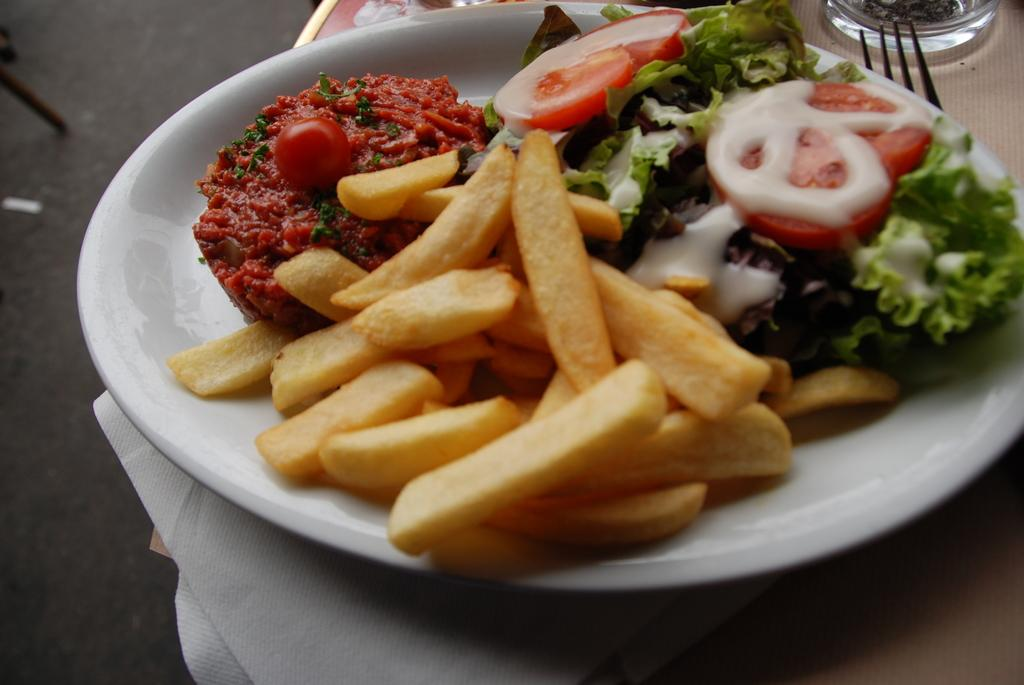What is on the plate in the image? The plate contains fries, chopped tomatoes, and leafy vegetables. What utensil is placed next to the plate? There is a fork next to the plate. What type of land can be seen in the image? There is no land visible in the image; it features a plate with food items and a fork. How does the bike move in the image? There is no bike present in the image. 